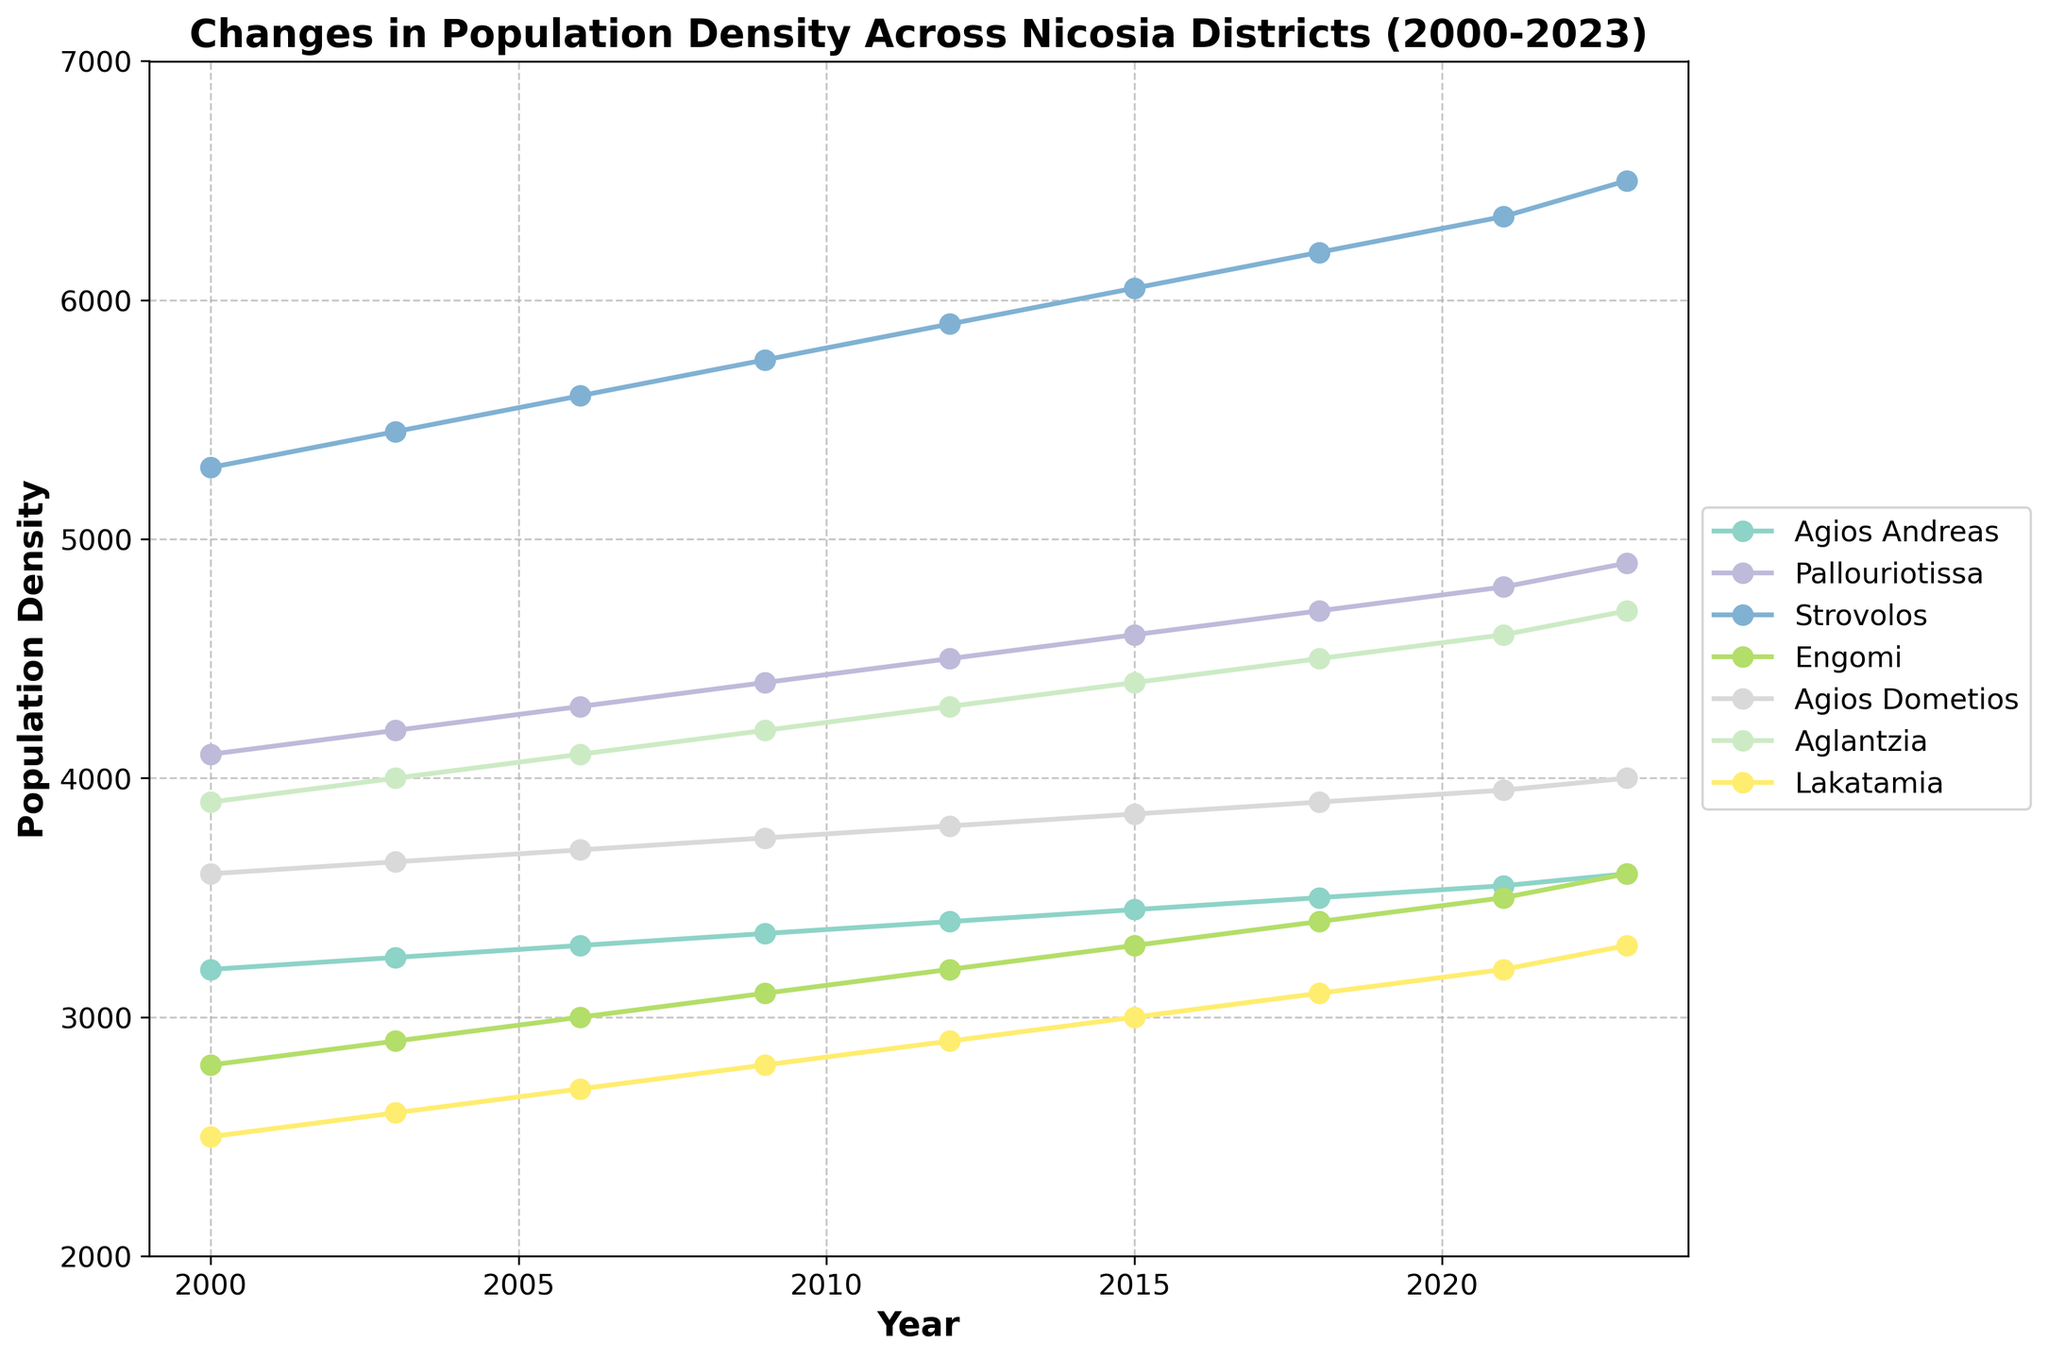What is the district with the highest population density in 2023? Look at the end of each line in the graph to determine which line reaches the highest value on the y-axis in the year 2023.
Answer: Strovolos How has the population density of Agios Dometios changed from 2000 to 2023? Compare the population density values of Agios Dometios at the starting year 2000 and the ending year 2023.
Answer: Increased from 3600 to 4000 Which district had the least increase in population density from 2000 to 2023? Calculate the difference in population density from 2000 to 2023 for each district and identify the smallest value.
Answer: Agios Andreas By how much did the population density of Engomi increase between 2003 and 2021? Subtract the population density of Engomi in 2003 from its value in 2021.
Answer: 600 Which district showed the steepest increase in population density during the period 2000-2023? Find the district whose line has the steepest overall upward slope between 2000 and 2023.
Answer: Strovolos In which year did Pallouriotissa's population density first reach 4500? Find the first year on the x-axis where Pallouriotissa's line crosses or reaches the 4500 mark on the y-axis.
Answer: 2012 What is the average population density of Aglantzia from 2000 to 2023? Sum the population densities of Aglantzia at each interval and divide by the number of intervals.
Answer: 4211.1 How does the population density trend of Lakatamia compare to Strovolos from 2000 to 2023? Observe and compare the upward or downward trends of the lines representing Lakatamia and Strovolos over the years.
Answer: Strovolos increased more rapidly What is the difference in population density between the highest and lowest districts in 2015? Identify the highest and lowest population densities among the districts in 2015 and find their difference.
Answer: 3550 Which districts have their population density lines intersecting between 2006 and 2009? Look for instances where two lines cross each other within the plotted years 2006 and 2009.
Answer: Aglantzia and Agios Dometios 